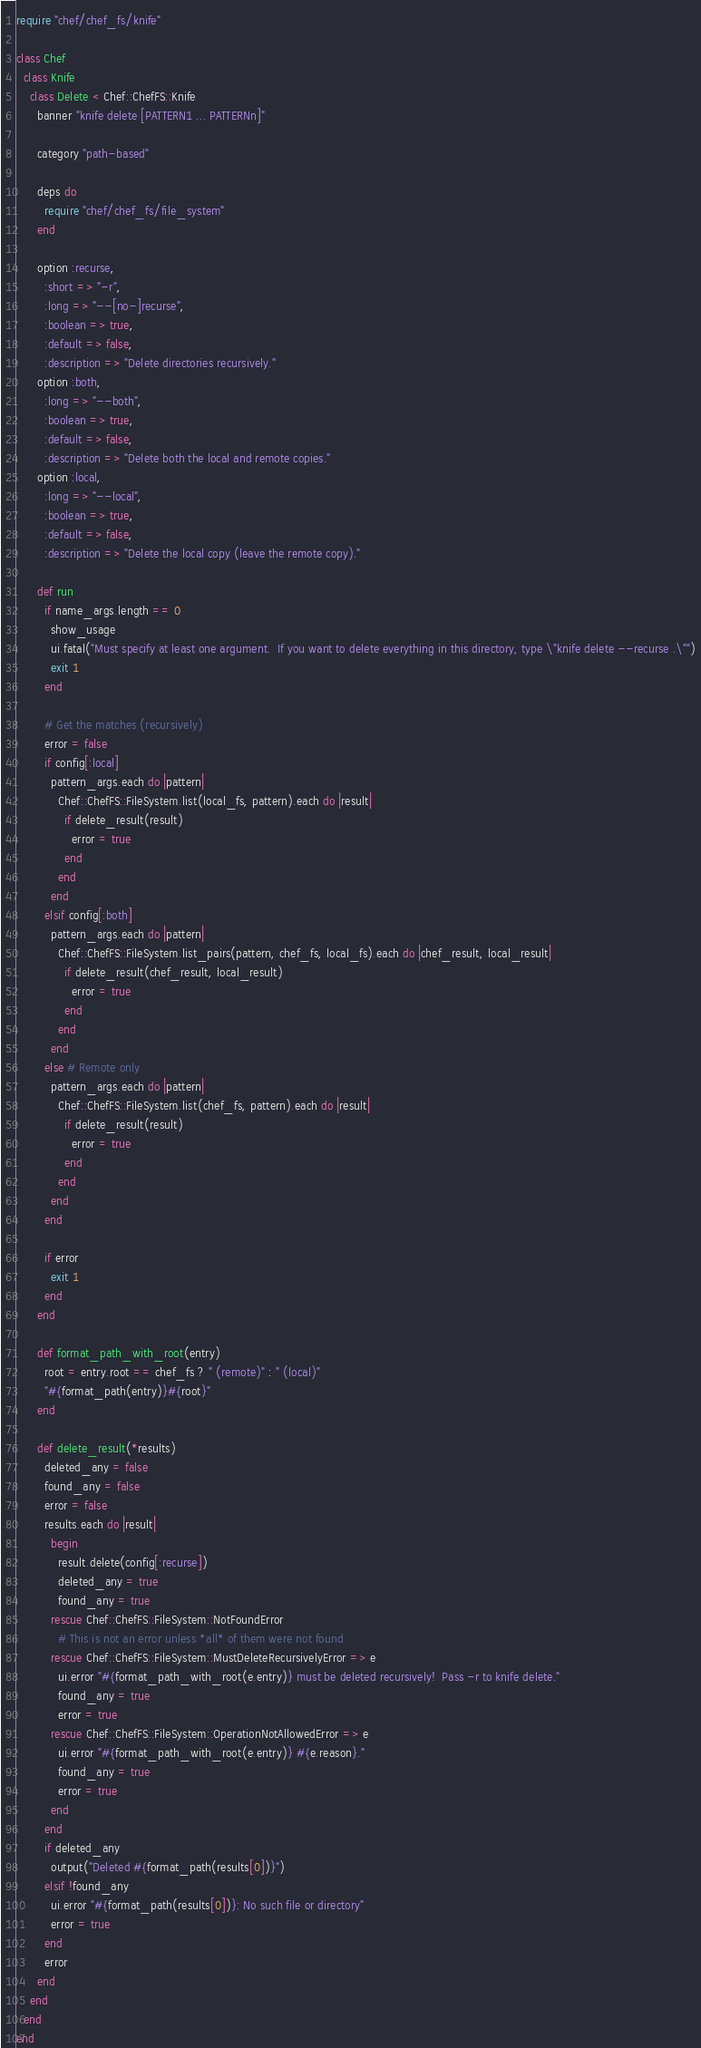Convert code to text. <code><loc_0><loc_0><loc_500><loc_500><_Ruby_>require "chef/chef_fs/knife"

class Chef
  class Knife
    class Delete < Chef::ChefFS::Knife
      banner "knife delete [PATTERN1 ... PATTERNn]"

      category "path-based"

      deps do
        require "chef/chef_fs/file_system"
      end

      option :recurse,
        :short => "-r",
        :long => "--[no-]recurse",
        :boolean => true,
        :default => false,
        :description => "Delete directories recursively."
      option :both,
        :long => "--both",
        :boolean => true,
        :default => false,
        :description => "Delete both the local and remote copies."
      option :local,
        :long => "--local",
        :boolean => true,
        :default => false,
        :description => "Delete the local copy (leave the remote copy)."

      def run
        if name_args.length == 0
          show_usage
          ui.fatal("Must specify at least one argument.  If you want to delete everything in this directory, type \"knife delete --recurse .\"")
          exit 1
        end

        # Get the matches (recursively)
        error = false
        if config[:local]
          pattern_args.each do |pattern|
            Chef::ChefFS::FileSystem.list(local_fs, pattern).each do |result|
              if delete_result(result)
                error = true
              end
            end
          end
        elsif config[:both]
          pattern_args.each do |pattern|
            Chef::ChefFS::FileSystem.list_pairs(pattern, chef_fs, local_fs).each do |chef_result, local_result|
              if delete_result(chef_result, local_result)
                error = true
              end
            end
          end
        else # Remote only
          pattern_args.each do |pattern|
            Chef::ChefFS::FileSystem.list(chef_fs, pattern).each do |result|
              if delete_result(result)
                error = true
              end
            end
          end
        end

        if error
          exit 1
        end
      end

      def format_path_with_root(entry)
        root = entry.root == chef_fs ? " (remote)" : " (local)"
        "#{format_path(entry)}#{root}"
      end

      def delete_result(*results)
        deleted_any = false
        found_any = false
        error = false
        results.each do |result|
          begin
            result.delete(config[:recurse])
            deleted_any = true
            found_any = true
          rescue Chef::ChefFS::FileSystem::NotFoundError
            # This is not an error unless *all* of them were not found
          rescue Chef::ChefFS::FileSystem::MustDeleteRecursivelyError => e
            ui.error "#{format_path_with_root(e.entry)} must be deleted recursively!  Pass -r to knife delete."
            found_any = true
            error = true
          rescue Chef::ChefFS::FileSystem::OperationNotAllowedError => e
            ui.error "#{format_path_with_root(e.entry)} #{e.reason}."
            found_any = true
            error = true
          end
        end
        if deleted_any
          output("Deleted #{format_path(results[0])}")
        elsif !found_any
          ui.error "#{format_path(results[0])}: No such file or directory"
          error = true
        end
        error
      end
    end
  end
end
</code> 